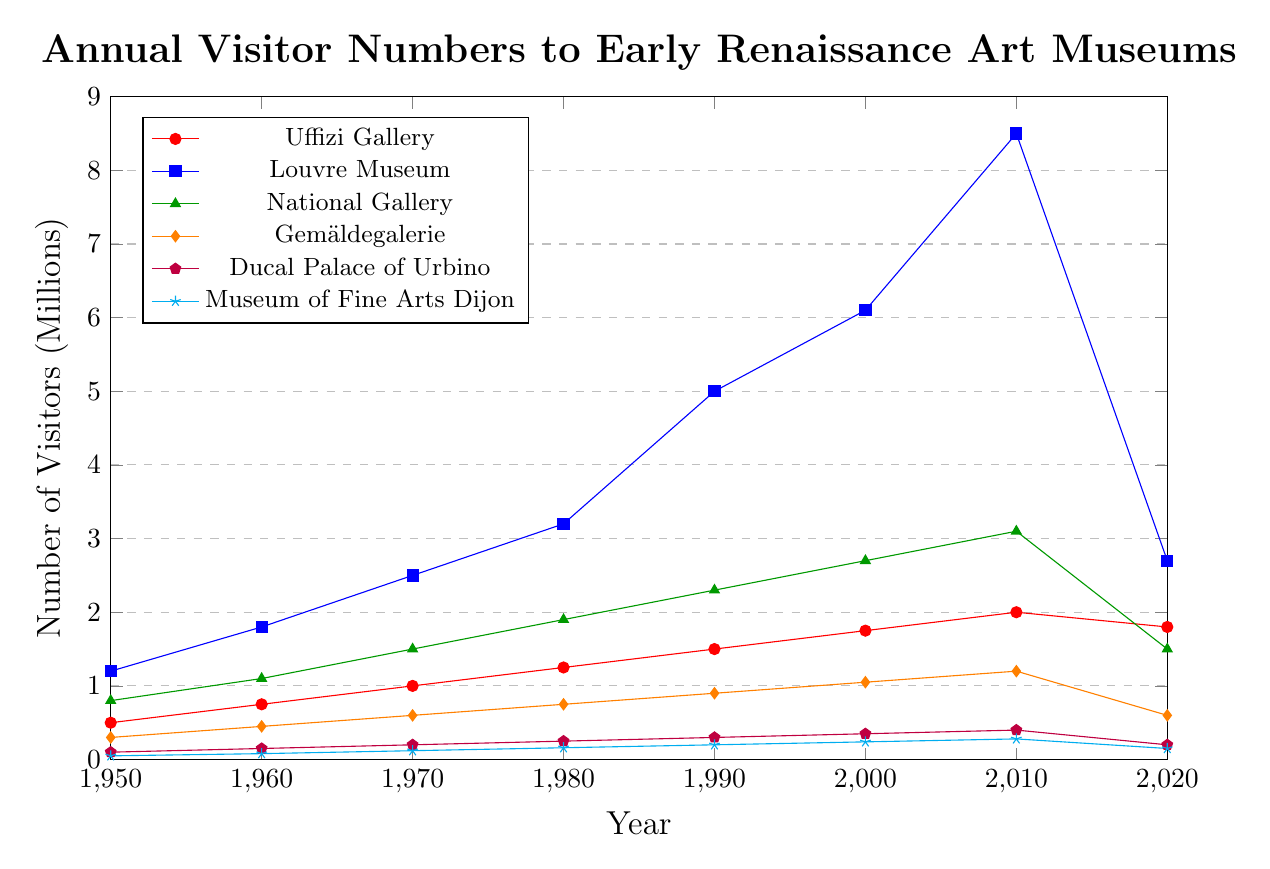What was the highest annual visitor count for the Louvre Museum? From the figure, the highest annual visitor count for different museums can be identified. The Louvre Museum reached its highest visitor count in 2010 with 8.5 million visitors.
Answer: 8.5 million In 2020, which museum experienced the greatest drop in visitor numbers compared to the previous decade? Compare the difference in visitor numbers from 2010 to 2020 for all museums. The Louvre Museum dropped from 8.5 million in 2010 to 2.7 million in 2020, which is a decrease of 5.8 million, the largest drop among the museums.
Answer: Louvre Museum Between which years did the Gemäldegalerie see its most substantial increase in visitors? Examine the visitor numbers for the Gemäldegalerie for each decade. The period from 1990 to 2000 shows an increase from 0.9 million to 1.05 million, the largest increase of 0.15 million visitors.
Answer: 1990-2000 Which museum had the smallest number of visitors in 1950 and how many did it have? From the figure, observe the visitor numbers in 1950. The Museum of Fine Arts Dijon had the smallest number of visitors, with only 50,000 visitors.
Answer: Museum of Fine Arts Dijon, 50,000 By how many millions did the National Gallery's visitor count increase from 1950 to 2020? Subtract the visitor count of the National Gallery in 1950 (0.8 million) from the count in 2020 (1.5 million). The increase is 1.5 - 0.8 = 0.7 million.
Answer: 0.7 million What is the average annual visitor count for the Ducal Palace of Urbino from 1950 to 2020? Sum the visitor counts for the Ducal Palace of Urbino across all decades and divide by the number of data points (8). (0.1 + 0.15 + 0.2 + 0.25 + 0.3 + 0.35 + 0.4 + 0.2) / 8 = 0.24 million.
Answer: 0.24 million Which two museums had an equal number of visitors in any given year and what was the count? The figure shows that in 2020, both the Gemäldegalerie and the Uffizi Gallery had the same number of visitors, 0.6 million.
Answer: Gemäldegalerie and Uffizi Gallery, 0.6 million Which museum showed a consistent increase in visitor numbers from 1950 until 2010? Check each museum for a consistent growth pattern from 1950 to 2010. The Uffizi Gallery shows continuous growth from 0.5 million in 1950 to 2 million in 2010.
Answer: Uffizi Gallery How did the number of visitors to the Museum of Fine Arts Dijon change from 2010 to 2020? Compare the visitor numbers from these two years. For the Museum of Fine Arts Dijon, the visitors decreased from 0.28 million in 2010 to 0.15 million in 2020, a drop of 0.13 million.
Answer: Decreased by 0.13 million 